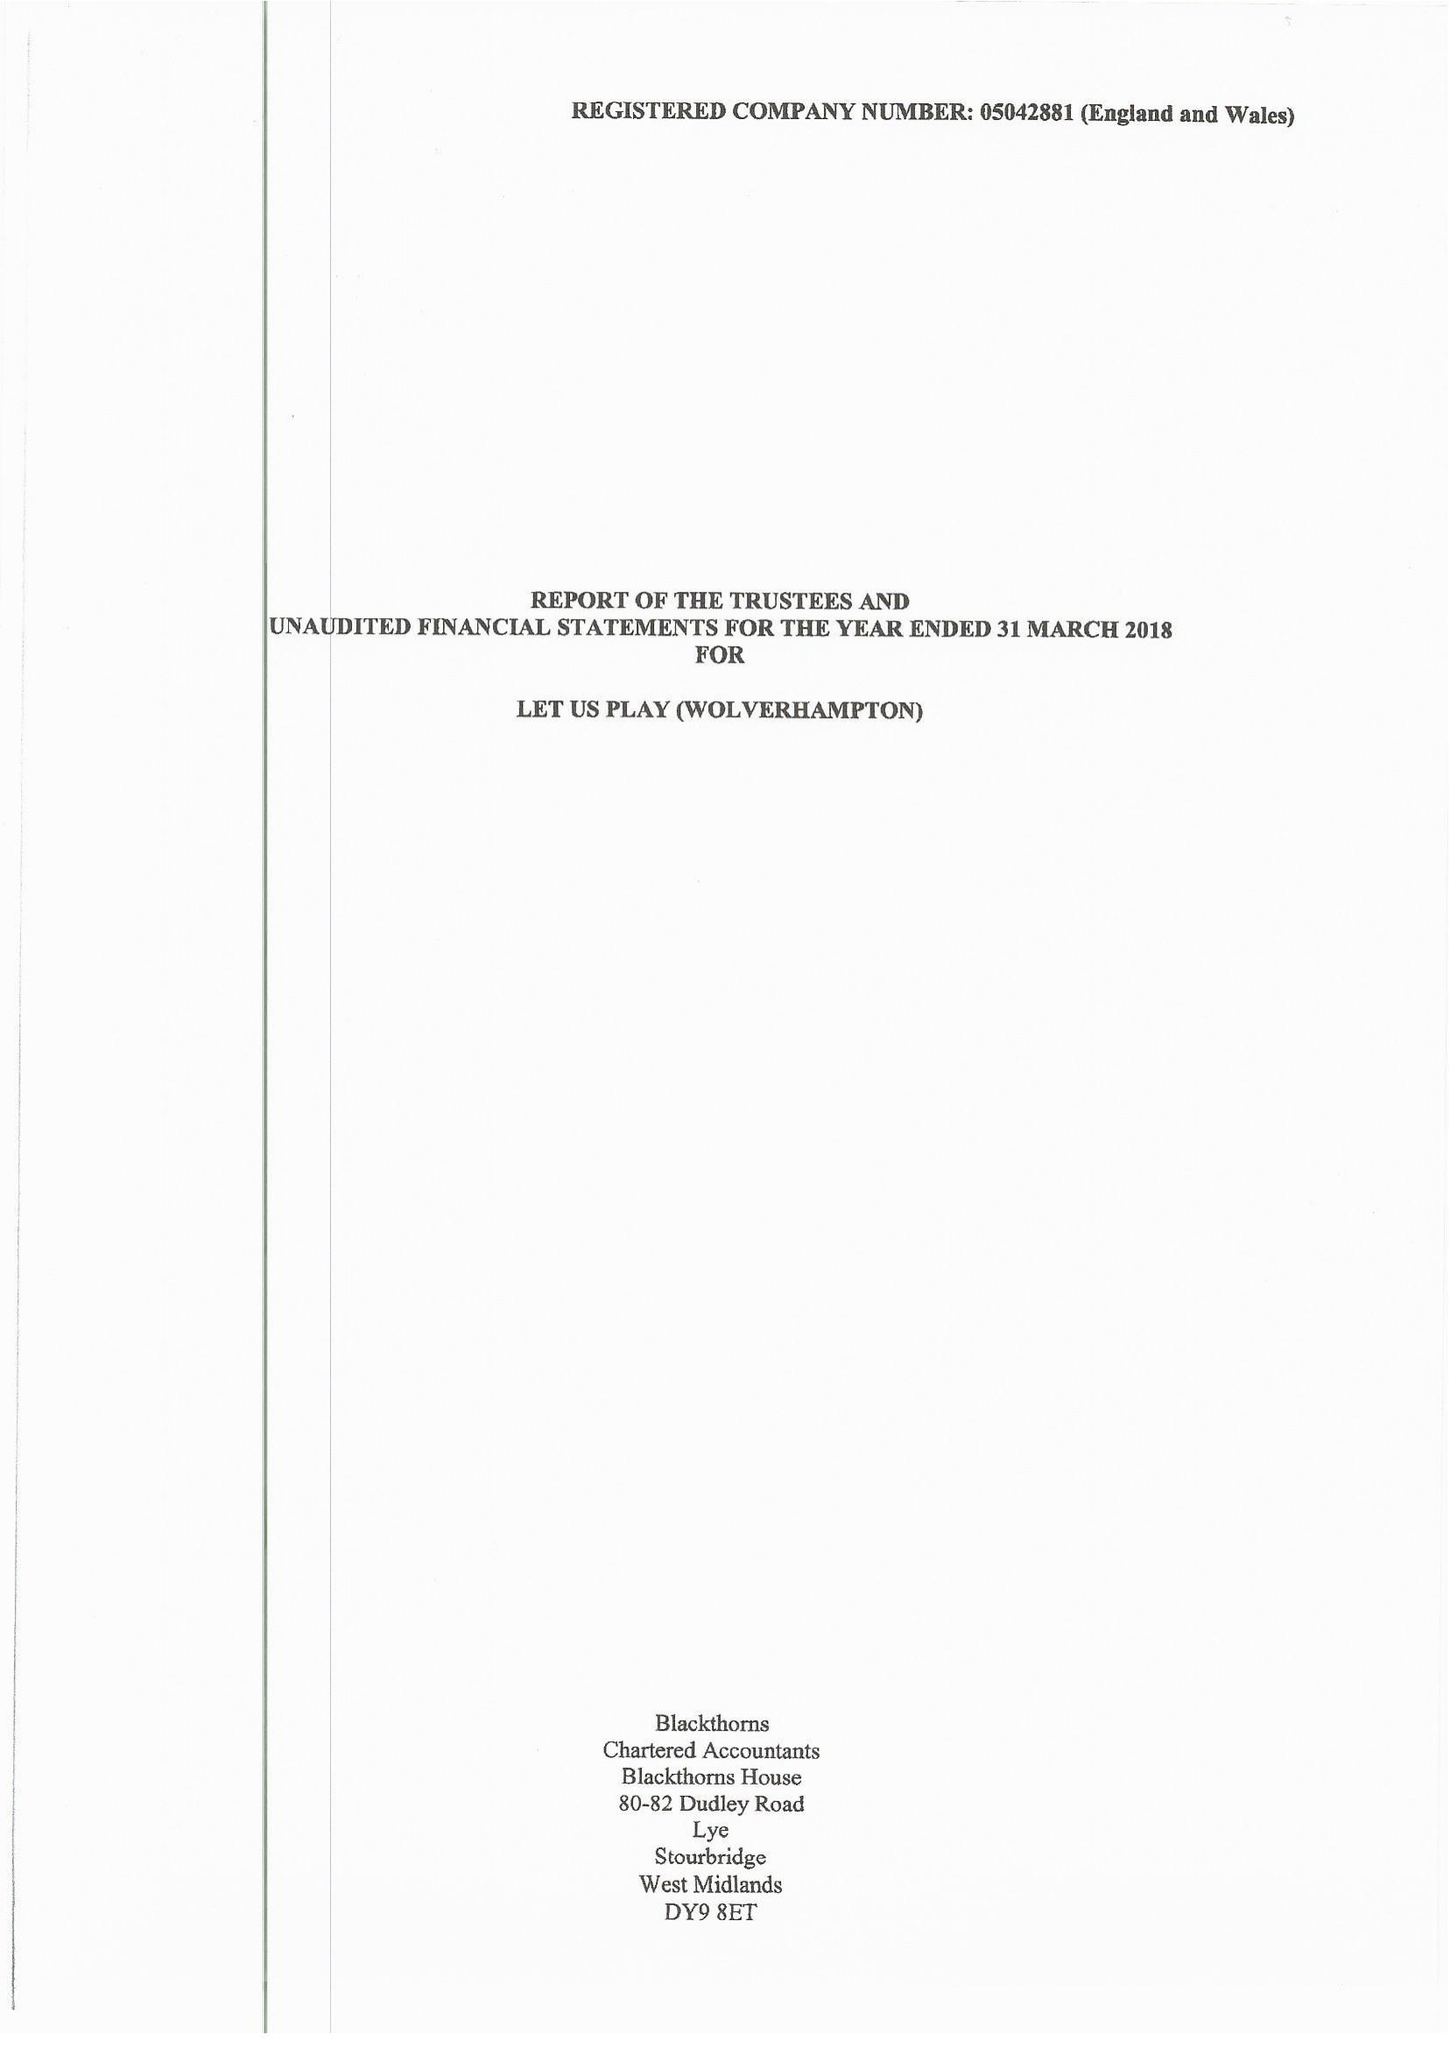What is the value for the spending_annually_in_british_pounds?
Answer the question using a single word or phrase. 126629.00 